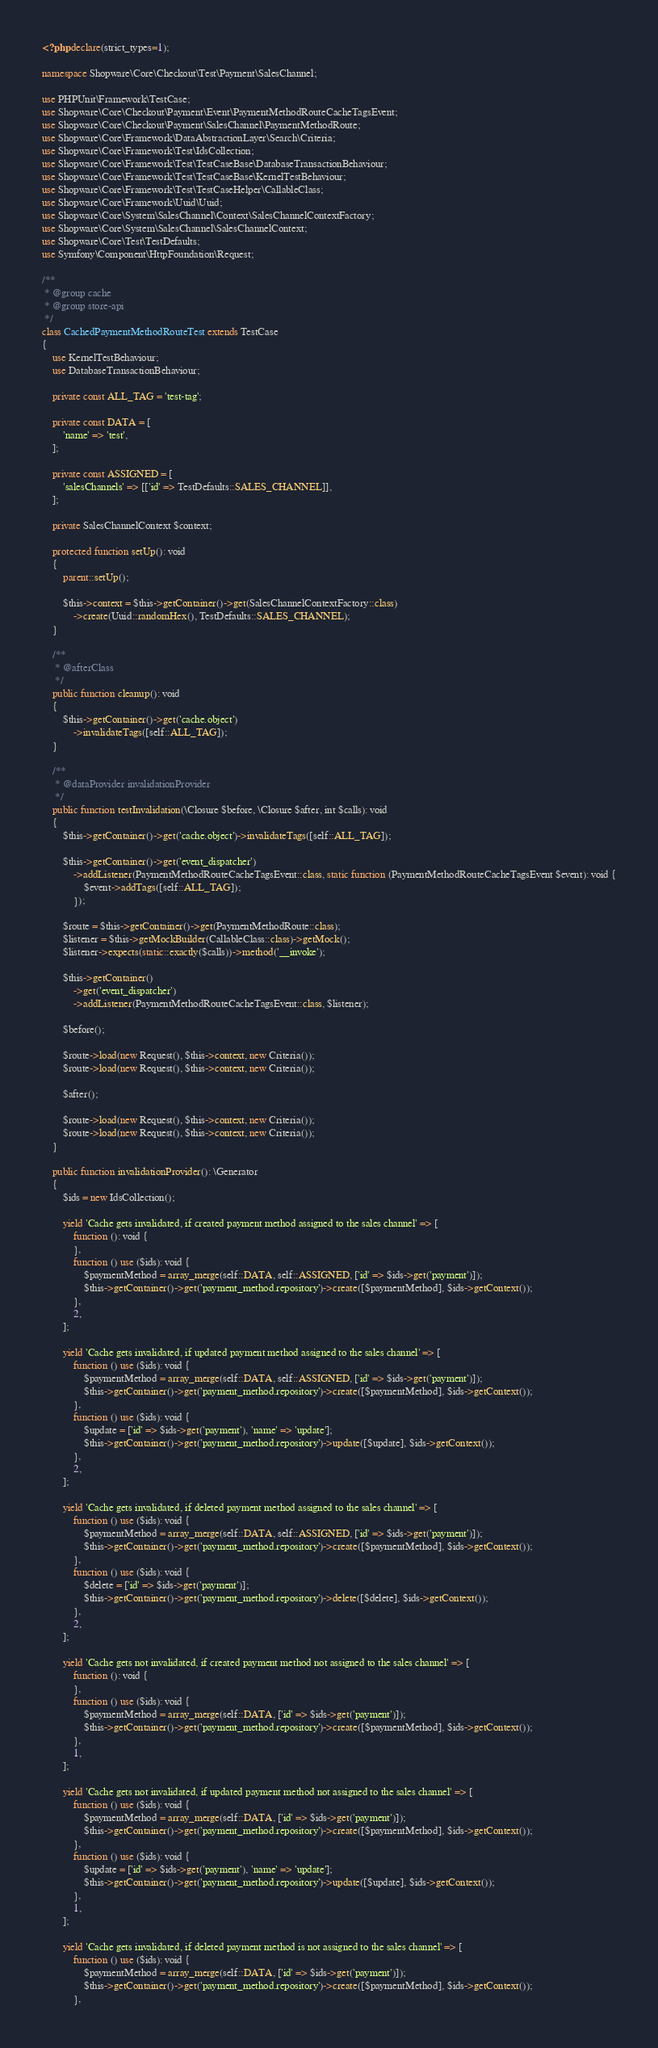Convert code to text. <code><loc_0><loc_0><loc_500><loc_500><_PHP_><?php declare(strict_types=1);

namespace Shopware\Core\Checkout\Test\Payment\SalesChannel;

use PHPUnit\Framework\TestCase;
use Shopware\Core\Checkout\Payment\Event\PaymentMethodRouteCacheTagsEvent;
use Shopware\Core\Checkout\Payment\SalesChannel\PaymentMethodRoute;
use Shopware\Core\Framework\DataAbstractionLayer\Search\Criteria;
use Shopware\Core\Framework\Test\IdsCollection;
use Shopware\Core\Framework\Test\TestCaseBase\DatabaseTransactionBehaviour;
use Shopware\Core\Framework\Test\TestCaseBase\KernelTestBehaviour;
use Shopware\Core\Framework\Test\TestCaseHelper\CallableClass;
use Shopware\Core\Framework\Uuid\Uuid;
use Shopware\Core\System\SalesChannel\Context\SalesChannelContextFactory;
use Shopware\Core\System\SalesChannel\SalesChannelContext;
use Shopware\Core\Test\TestDefaults;
use Symfony\Component\HttpFoundation\Request;

/**
 * @group cache
 * @group store-api
 */
class CachedPaymentMethodRouteTest extends TestCase
{
    use KernelTestBehaviour;
    use DatabaseTransactionBehaviour;

    private const ALL_TAG = 'test-tag';

    private const DATA = [
        'name' => 'test',
    ];

    private const ASSIGNED = [
        'salesChannels' => [['id' => TestDefaults::SALES_CHANNEL]],
    ];

    private SalesChannelContext $context;

    protected function setUp(): void
    {
        parent::setUp();

        $this->context = $this->getContainer()->get(SalesChannelContextFactory::class)
            ->create(Uuid::randomHex(), TestDefaults::SALES_CHANNEL);
    }

    /**
     * @afterClass
     */
    public function cleanup(): void
    {
        $this->getContainer()->get('cache.object')
            ->invalidateTags([self::ALL_TAG]);
    }

    /**
     * @dataProvider invalidationProvider
     */
    public function testInvalidation(\Closure $before, \Closure $after, int $calls): void
    {
        $this->getContainer()->get('cache.object')->invalidateTags([self::ALL_TAG]);

        $this->getContainer()->get('event_dispatcher')
            ->addListener(PaymentMethodRouteCacheTagsEvent::class, static function (PaymentMethodRouteCacheTagsEvent $event): void {
                $event->addTags([self::ALL_TAG]);
            });

        $route = $this->getContainer()->get(PaymentMethodRoute::class);
        $listener = $this->getMockBuilder(CallableClass::class)->getMock();
        $listener->expects(static::exactly($calls))->method('__invoke');

        $this->getContainer()
            ->get('event_dispatcher')
            ->addListener(PaymentMethodRouteCacheTagsEvent::class, $listener);

        $before();

        $route->load(new Request(), $this->context, new Criteria());
        $route->load(new Request(), $this->context, new Criteria());

        $after();

        $route->load(new Request(), $this->context, new Criteria());
        $route->load(new Request(), $this->context, new Criteria());
    }

    public function invalidationProvider(): \Generator
    {
        $ids = new IdsCollection();

        yield 'Cache gets invalidated, if created payment method assigned to the sales channel' => [
            function (): void {
            },
            function () use ($ids): void {
                $paymentMethod = array_merge(self::DATA, self::ASSIGNED, ['id' => $ids->get('payment')]);
                $this->getContainer()->get('payment_method.repository')->create([$paymentMethod], $ids->getContext());
            },
            2,
        ];

        yield 'Cache gets invalidated, if updated payment method assigned to the sales channel' => [
            function () use ($ids): void {
                $paymentMethod = array_merge(self::DATA, self::ASSIGNED, ['id' => $ids->get('payment')]);
                $this->getContainer()->get('payment_method.repository')->create([$paymentMethod], $ids->getContext());
            },
            function () use ($ids): void {
                $update = ['id' => $ids->get('payment'), 'name' => 'update'];
                $this->getContainer()->get('payment_method.repository')->update([$update], $ids->getContext());
            },
            2,
        ];

        yield 'Cache gets invalidated, if deleted payment method assigned to the sales channel' => [
            function () use ($ids): void {
                $paymentMethod = array_merge(self::DATA, self::ASSIGNED, ['id' => $ids->get('payment')]);
                $this->getContainer()->get('payment_method.repository')->create([$paymentMethod], $ids->getContext());
            },
            function () use ($ids): void {
                $delete = ['id' => $ids->get('payment')];
                $this->getContainer()->get('payment_method.repository')->delete([$delete], $ids->getContext());
            },
            2,
        ];

        yield 'Cache gets not invalidated, if created payment method not assigned to the sales channel' => [
            function (): void {
            },
            function () use ($ids): void {
                $paymentMethod = array_merge(self::DATA, ['id' => $ids->get('payment')]);
                $this->getContainer()->get('payment_method.repository')->create([$paymentMethod], $ids->getContext());
            },
            1,
        ];

        yield 'Cache gets not invalidated, if updated payment method not assigned to the sales channel' => [
            function () use ($ids): void {
                $paymentMethod = array_merge(self::DATA, ['id' => $ids->get('payment')]);
                $this->getContainer()->get('payment_method.repository')->create([$paymentMethod], $ids->getContext());
            },
            function () use ($ids): void {
                $update = ['id' => $ids->get('payment'), 'name' => 'update'];
                $this->getContainer()->get('payment_method.repository')->update([$update], $ids->getContext());
            },
            1,
        ];

        yield 'Cache gets invalidated, if deleted payment method is not assigned to the sales channel' => [
            function () use ($ids): void {
                $paymentMethod = array_merge(self::DATA, ['id' => $ids->get('payment')]);
                $this->getContainer()->get('payment_method.repository')->create([$paymentMethod], $ids->getContext());
            },</code> 